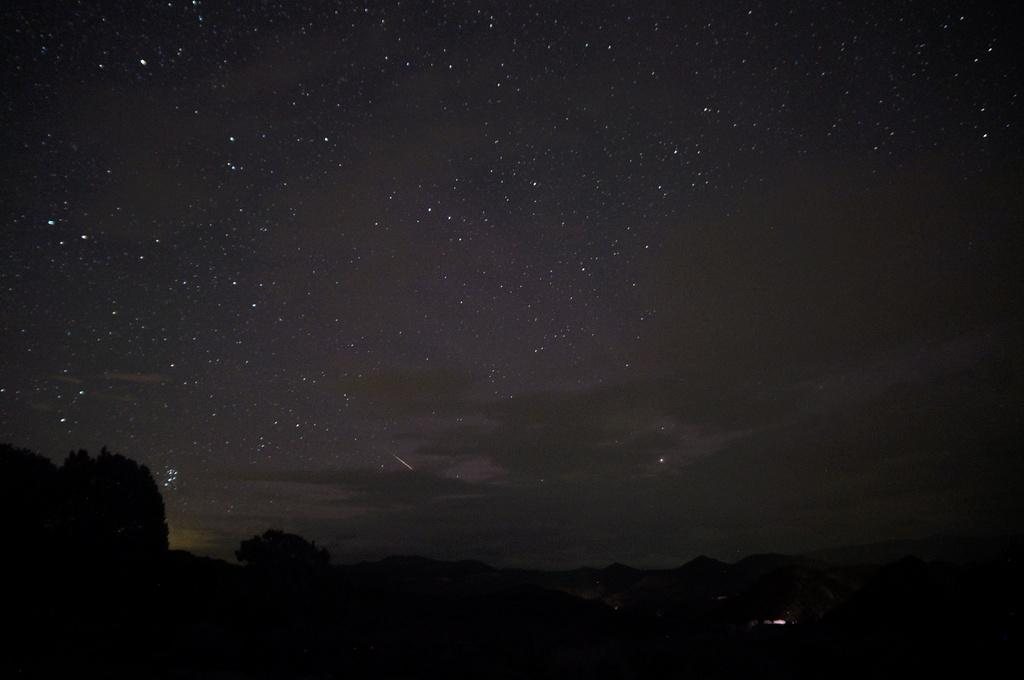What type of vegetation can be seen in the image? There are trees in the image. What type of geographical feature is present in the image? There are hills in the image. What can be seen in the sky in the background of the image? Stars are visible in the sky in the background of the image. Can you provide an example of a toad in the image? There is no toad present in the image. How many fingers can be seen pointing at the stars in the image? There are no fingers visible in the image, as it features trees, hills, and stars in the sky. 